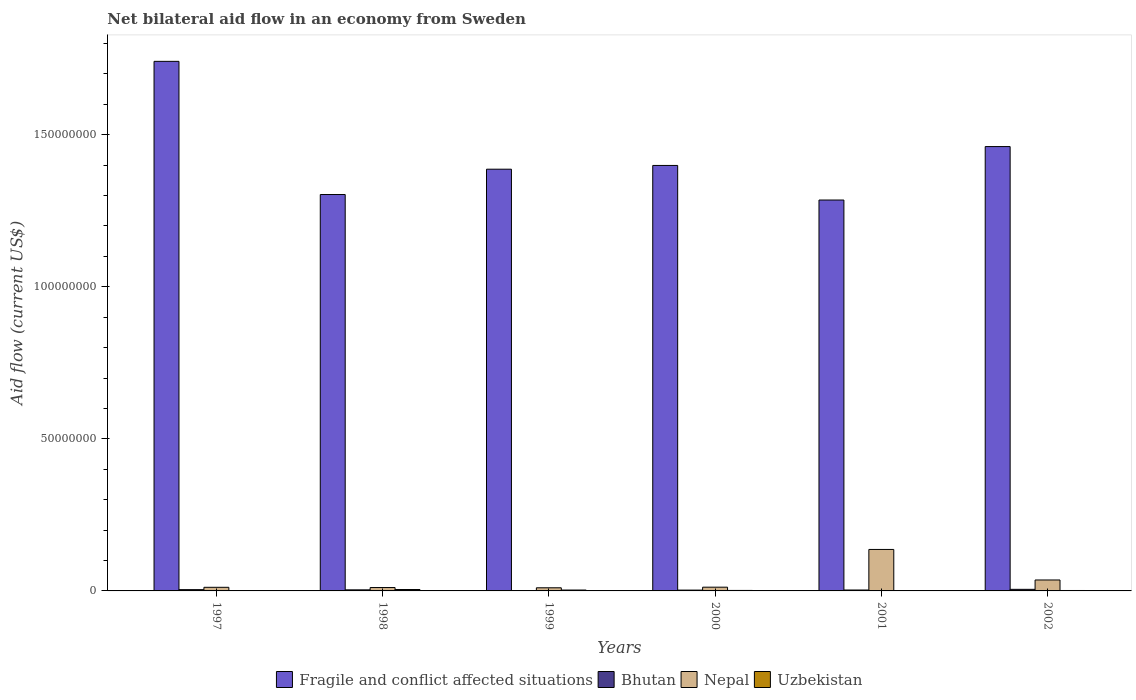How many different coloured bars are there?
Your answer should be compact. 4. Are the number of bars per tick equal to the number of legend labels?
Give a very brief answer. Yes. Are the number of bars on each tick of the X-axis equal?
Make the answer very short. Yes. How many bars are there on the 1st tick from the left?
Offer a terse response. 4. How many bars are there on the 6th tick from the right?
Give a very brief answer. 4. In how many cases, is the number of bars for a given year not equal to the number of legend labels?
Provide a short and direct response. 0. Across all years, what is the minimum net bilateral aid flow in Uzbekistan?
Provide a short and direct response. 4.00e+04. In which year was the net bilateral aid flow in Fragile and conflict affected situations maximum?
Provide a short and direct response. 1997. What is the total net bilateral aid flow in Nepal in the graph?
Your answer should be very brief. 2.18e+07. What is the difference between the net bilateral aid flow in Fragile and conflict affected situations in 1999 and that in 2001?
Ensure brevity in your answer.  1.01e+07. What is the difference between the net bilateral aid flow in Uzbekistan in 1997 and the net bilateral aid flow in Fragile and conflict affected situations in 1998?
Your answer should be very brief. -1.30e+08. What is the average net bilateral aid flow in Fragile and conflict affected situations per year?
Your answer should be very brief. 1.43e+08. In the year 2002, what is the difference between the net bilateral aid flow in Fragile and conflict affected situations and net bilateral aid flow in Nepal?
Provide a short and direct response. 1.43e+08. What is the ratio of the net bilateral aid flow in Fragile and conflict affected situations in 1997 to that in 1998?
Give a very brief answer. 1.34. Is the net bilateral aid flow in Uzbekistan in 1997 less than that in 2000?
Ensure brevity in your answer.  Yes. Is the difference between the net bilateral aid flow in Fragile and conflict affected situations in 1999 and 2000 greater than the difference between the net bilateral aid flow in Nepal in 1999 and 2000?
Offer a terse response. No. What is the difference between the highest and the second highest net bilateral aid flow in Fragile and conflict affected situations?
Your answer should be compact. 2.80e+07. What is the difference between the highest and the lowest net bilateral aid flow in Bhutan?
Provide a succinct answer. 4.50e+05. In how many years, is the net bilateral aid flow in Bhutan greater than the average net bilateral aid flow in Bhutan taken over all years?
Your response must be concise. 3. Is the sum of the net bilateral aid flow in Nepal in 1998 and 2001 greater than the maximum net bilateral aid flow in Uzbekistan across all years?
Keep it short and to the point. Yes. What does the 1st bar from the left in 1997 represents?
Provide a short and direct response. Fragile and conflict affected situations. What does the 4th bar from the right in 1999 represents?
Make the answer very short. Fragile and conflict affected situations. Is it the case that in every year, the sum of the net bilateral aid flow in Nepal and net bilateral aid flow in Bhutan is greater than the net bilateral aid flow in Fragile and conflict affected situations?
Ensure brevity in your answer.  No. How many years are there in the graph?
Make the answer very short. 6. Does the graph contain any zero values?
Ensure brevity in your answer.  No. What is the title of the graph?
Offer a very short reply. Net bilateral aid flow in an economy from Sweden. Does "Poland" appear as one of the legend labels in the graph?
Your answer should be very brief. No. What is the label or title of the X-axis?
Your answer should be compact. Years. What is the Aid flow (current US$) in Fragile and conflict affected situations in 1997?
Give a very brief answer. 1.74e+08. What is the Aid flow (current US$) in Nepal in 1997?
Give a very brief answer. 1.19e+06. What is the Aid flow (current US$) of Fragile and conflict affected situations in 1998?
Make the answer very short. 1.30e+08. What is the Aid flow (current US$) of Bhutan in 1998?
Ensure brevity in your answer.  3.50e+05. What is the Aid flow (current US$) of Nepal in 1998?
Your response must be concise. 1.11e+06. What is the Aid flow (current US$) of Uzbekistan in 1998?
Your response must be concise. 4.60e+05. What is the Aid flow (current US$) of Fragile and conflict affected situations in 1999?
Provide a short and direct response. 1.39e+08. What is the Aid flow (current US$) in Nepal in 1999?
Make the answer very short. 1.03e+06. What is the Aid flow (current US$) of Fragile and conflict affected situations in 2000?
Your answer should be very brief. 1.40e+08. What is the Aid flow (current US$) in Bhutan in 2000?
Your answer should be compact. 2.70e+05. What is the Aid flow (current US$) of Nepal in 2000?
Ensure brevity in your answer.  1.23e+06. What is the Aid flow (current US$) of Fragile and conflict affected situations in 2001?
Offer a terse response. 1.29e+08. What is the Aid flow (current US$) in Nepal in 2001?
Make the answer very short. 1.36e+07. What is the Aid flow (current US$) of Uzbekistan in 2001?
Provide a succinct answer. 4.00e+04. What is the Aid flow (current US$) of Fragile and conflict affected situations in 2002?
Offer a very short reply. 1.46e+08. What is the Aid flow (current US$) of Bhutan in 2002?
Keep it short and to the point. 5.20e+05. What is the Aid flow (current US$) in Nepal in 2002?
Provide a short and direct response. 3.60e+06. What is the Aid flow (current US$) of Uzbekistan in 2002?
Your answer should be compact. 1.40e+05. Across all years, what is the maximum Aid flow (current US$) of Fragile and conflict affected situations?
Provide a succinct answer. 1.74e+08. Across all years, what is the maximum Aid flow (current US$) of Bhutan?
Offer a very short reply. 5.20e+05. Across all years, what is the maximum Aid flow (current US$) of Nepal?
Your answer should be compact. 1.36e+07. Across all years, what is the maximum Aid flow (current US$) of Uzbekistan?
Offer a very short reply. 4.60e+05. Across all years, what is the minimum Aid flow (current US$) in Fragile and conflict affected situations?
Offer a terse response. 1.29e+08. Across all years, what is the minimum Aid flow (current US$) in Bhutan?
Your answer should be very brief. 7.00e+04. Across all years, what is the minimum Aid flow (current US$) of Nepal?
Ensure brevity in your answer.  1.03e+06. Across all years, what is the minimum Aid flow (current US$) in Uzbekistan?
Give a very brief answer. 4.00e+04. What is the total Aid flow (current US$) in Fragile and conflict affected situations in the graph?
Give a very brief answer. 8.58e+08. What is the total Aid flow (current US$) of Bhutan in the graph?
Your answer should be very brief. 1.93e+06. What is the total Aid flow (current US$) of Nepal in the graph?
Offer a terse response. 2.18e+07. What is the total Aid flow (current US$) in Uzbekistan in the graph?
Ensure brevity in your answer.  1.22e+06. What is the difference between the Aid flow (current US$) of Fragile and conflict affected situations in 1997 and that in 1998?
Provide a short and direct response. 4.38e+07. What is the difference between the Aid flow (current US$) in Uzbekistan in 1997 and that in 1998?
Your answer should be very brief. -3.30e+05. What is the difference between the Aid flow (current US$) in Fragile and conflict affected situations in 1997 and that in 1999?
Offer a terse response. 3.55e+07. What is the difference between the Aid flow (current US$) in Nepal in 1997 and that in 1999?
Make the answer very short. 1.60e+05. What is the difference between the Aid flow (current US$) in Fragile and conflict affected situations in 1997 and that in 2000?
Your answer should be compact. 3.42e+07. What is the difference between the Aid flow (current US$) in Bhutan in 1997 and that in 2000?
Make the answer very short. 1.50e+05. What is the difference between the Aid flow (current US$) in Fragile and conflict affected situations in 1997 and that in 2001?
Keep it short and to the point. 4.56e+07. What is the difference between the Aid flow (current US$) of Nepal in 1997 and that in 2001?
Offer a terse response. -1.24e+07. What is the difference between the Aid flow (current US$) of Fragile and conflict affected situations in 1997 and that in 2002?
Make the answer very short. 2.80e+07. What is the difference between the Aid flow (current US$) in Nepal in 1997 and that in 2002?
Give a very brief answer. -2.41e+06. What is the difference between the Aid flow (current US$) of Uzbekistan in 1997 and that in 2002?
Provide a succinct answer. -10000. What is the difference between the Aid flow (current US$) of Fragile and conflict affected situations in 1998 and that in 1999?
Give a very brief answer. -8.33e+06. What is the difference between the Aid flow (current US$) in Nepal in 1998 and that in 1999?
Give a very brief answer. 8.00e+04. What is the difference between the Aid flow (current US$) of Fragile and conflict affected situations in 1998 and that in 2000?
Keep it short and to the point. -9.56e+06. What is the difference between the Aid flow (current US$) of Uzbekistan in 1998 and that in 2000?
Make the answer very short. 3.00e+05. What is the difference between the Aid flow (current US$) in Fragile and conflict affected situations in 1998 and that in 2001?
Keep it short and to the point. 1.81e+06. What is the difference between the Aid flow (current US$) of Nepal in 1998 and that in 2001?
Your answer should be compact. -1.25e+07. What is the difference between the Aid flow (current US$) in Fragile and conflict affected situations in 1998 and that in 2002?
Ensure brevity in your answer.  -1.58e+07. What is the difference between the Aid flow (current US$) of Bhutan in 1998 and that in 2002?
Ensure brevity in your answer.  -1.70e+05. What is the difference between the Aid flow (current US$) of Nepal in 1998 and that in 2002?
Your answer should be compact. -2.49e+06. What is the difference between the Aid flow (current US$) in Fragile and conflict affected situations in 1999 and that in 2000?
Your answer should be very brief. -1.23e+06. What is the difference between the Aid flow (current US$) of Nepal in 1999 and that in 2000?
Offer a very short reply. -2.00e+05. What is the difference between the Aid flow (current US$) in Fragile and conflict affected situations in 1999 and that in 2001?
Your answer should be compact. 1.01e+07. What is the difference between the Aid flow (current US$) of Bhutan in 1999 and that in 2001?
Give a very brief answer. -2.30e+05. What is the difference between the Aid flow (current US$) in Nepal in 1999 and that in 2001?
Provide a short and direct response. -1.26e+07. What is the difference between the Aid flow (current US$) in Uzbekistan in 1999 and that in 2001?
Offer a very short reply. 2.50e+05. What is the difference between the Aid flow (current US$) in Fragile and conflict affected situations in 1999 and that in 2002?
Give a very brief answer. -7.44e+06. What is the difference between the Aid flow (current US$) in Bhutan in 1999 and that in 2002?
Ensure brevity in your answer.  -4.50e+05. What is the difference between the Aid flow (current US$) of Nepal in 1999 and that in 2002?
Keep it short and to the point. -2.57e+06. What is the difference between the Aid flow (current US$) of Uzbekistan in 1999 and that in 2002?
Provide a short and direct response. 1.50e+05. What is the difference between the Aid flow (current US$) of Fragile and conflict affected situations in 2000 and that in 2001?
Your answer should be very brief. 1.14e+07. What is the difference between the Aid flow (current US$) of Bhutan in 2000 and that in 2001?
Provide a short and direct response. -3.00e+04. What is the difference between the Aid flow (current US$) in Nepal in 2000 and that in 2001?
Your response must be concise. -1.24e+07. What is the difference between the Aid flow (current US$) in Fragile and conflict affected situations in 2000 and that in 2002?
Offer a very short reply. -6.21e+06. What is the difference between the Aid flow (current US$) in Bhutan in 2000 and that in 2002?
Provide a succinct answer. -2.50e+05. What is the difference between the Aid flow (current US$) in Nepal in 2000 and that in 2002?
Provide a succinct answer. -2.37e+06. What is the difference between the Aid flow (current US$) of Fragile and conflict affected situations in 2001 and that in 2002?
Keep it short and to the point. -1.76e+07. What is the difference between the Aid flow (current US$) of Nepal in 2001 and that in 2002?
Make the answer very short. 1.00e+07. What is the difference between the Aid flow (current US$) of Uzbekistan in 2001 and that in 2002?
Ensure brevity in your answer.  -1.00e+05. What is the difference between the Aid flow (current US$) of Fragile and conflict affected situations in 1997 and the Aid flow (current US$) of Bhutan in 1998?
Give a very brief answer. 1.74e+08. What is the difference between the Aid flow (current US$) of Fragile and conflict affected situations in 1997 and the Aid flow (current US$) of Nepal in 1998?
Your answer should be very brief. 1.73e+08. What is the difference between the Aid flow (current US$) in Fragile and conflict affected situations in 1997 and the Aid flow (current US$) in Uzbekistan in 1998?
Ensure brevity in your answer.  1.74e+08. What is the difference between the Aid flow (current US$) of Bhutan in 1997 and the Aid flow (current US$) of Nepal in 1998?
Keep it short and to the point. -6.90e+05. What is the difference between the Aid flow (current US$) in Nepal in 1997 and the Aid flow (current US$) in Uzbekistan in 1998?
Offer a very short reply. 7.30e+05. What is the difference between the Aid flow (current US$) in Fragile and conflict affected situations in 1997 and the Aid flow (current US$) in Bhutan in 1999?
Your answer should be compact. 1.74e+08. What is the difference between the Aid flow (current US$) in Fragile and conflict affected situations in 1997 and the Aid flow (current US$) in Nepal in 1999?
Offer a terse response. 1.73e+08. What is the difference between the Aid flow (current US$) of Fragile and conflict affected situations in 1997 and the Aid flow (current US$) of Uzbekistan in 1999?
Your response must be concise. 1.74e+08. What is the difference between the Aid flow (current US$) of Bhutan in 1997 and the Aid flow (current US$) of Nepal in 1999?
Keep it short and to the point. -6.10e+05. What is the difference between the Aid flow (current US$) in Fragile and conflict affected situations in 1997 and the Aid flow (current US$) in Bhutan in 2000?
Keep it short and to the point. 1.74e+08. What is the difference between the Aid flow (current US$) in Fragile and conflict affected situations in 1997 and the Aid flow (current US$) in Nepal in 2000?
Your answer should be compact. 1.73e+08. What is the difference between the Aid flow (current US$) of Fragile and conflict affected situations in 1997 and the Aid flow (current US$) of Uzbekistan in 2000?
Make the answer very short. 1.74e+08. What is the difference between the Aid flow (current US$) of Bhutan in 1997 and the Aid flow (current US$) of Nepal in 2000?
Offer a very short reply. -8.10e+05. What is the difference between the Aid flow (current US$) of Nepal in 1997 and the Aid flow (current US$) of Uzbekistan in 2000?
Offer a very short reply. 1.03e+06. What is the difference between the Aid flow (current US$) of Fragile and conflict affected situations in 1997 and the Aid flow (current US$) of Bhutan in 2001?
Keep it short and to the point. 1.74e+08. What is the difference between the Aid flow (current US$) in Fragile and conflict affected situations in 1997 and the Aid flow (current US$) in Nepal in 2001?
Ensure brevity in your answer.  1.60e+08. What is the difference between the Aid flow (current US$) in Fragile and conflict affected situations in 1997 and the Aid flow (current US$) in Uzbekistan in 2001?
Your answer should be very brief. 1.74e+08. What is the difference between the Aid flow (current US$) of Bhutan in 1997 and the Aid flow (current US$) of Nepal in 2001?
Your answer should be very brief. -1.32e+07. What is the difference between the Aid flow (current US$) of Nepal in 1997 and the Aid flow (current US$) of Uzbekistan in 2001?
Your answer should be very brief. 1.15e+06. What is the difference between the Aid flow (current US$) of Fragile and conflict affected situations in 1997 and the Aid flow (current US$) of Bhutan in 2002?
Provide a short and direct response. 1.74e+08. What is the difference between the Aid flow (current US$) in Fragile and conflict affected situations in 1997 and the Aid flow (current US$) in Nepal in 2002?
Ensure brevity in your answer.  1.71e+08. What is the difference between the Aid flow (current US$) in Fragile and conflict affected situations in 1997 and the Aid flow (current US$) in Uzbekistan in 2002?
Make the answer very short. 1.74e+08. What is the difference between the Aid flow (current US$) of Bhutan in 1997 and the Aid flow (current US$) of Nepal in 2002?
Offer a very short reply. -3.18e+06. What is the difference between the Aid flow (current US$) in Nepal in 1997 and the Aid flow (current US$) in Uzbekistan in 2002?
Offer a very short reply. 1.05e+06. What is the difference between the Aid flow (current US$) in Fragile and conflict affected situations in 1998 and the Aid flow (current US$) in Bhutan in 1999?
Your answer should be very brief. 1.30e+08. What is the difference between the Aid flow (current US$) in Fragile and conflict affected situations in 1998 and the Aid flow (current US$) in Nepal in 1999?
Your answer should be very brief. 1.29e+08. What is the difference between the Aid flow (current US$) of Fragile and conflict affected situations in 1998 and the Aid flow (current US$) of Uzbekistan in 1999?
Your answer should be compact. 1.30e+08. What is the difference between the Aid flow (current US$) in Bhutan in 1998 and the Aid flow (current US$) in Nepal in 1999?
Keep it short and to the point. -6.80e+05. What is the difference between the Aid flow (current US$) in Bhutan in 1998 and the Aid flow (current US$) in Uzbekistan in 1999?
Give a very brief answer. 6.00e+04. What is the difference between the Aid flow (current US$) of Nepal in 1998 and the Aid flow (current US$) of Uzbekistan in 1999?
Your answer should be very brief. 8.20e+05. What is the difference between the Aid flow (current US$) in Fragile and conflict affected situations in 1998 and the Aid flow (current US$) in Bhutan in 2000?
Ensure brevity in your answer.  1.30e+08. What is the difference between the Aid flow (current US$) of Fragile and conflict affected situations in 1998 and the Aid flow (current US$) of Nepal in 2000?
Your answer should be very brief. 1.29e+08. What is the difference between the Aid flow (current US$) in Fragile and conflict affected situations in 1998 and the Aid flow (current US$) in Uzbekistan in 2000?
Your response must be concise. 1.30e+08. What is the difference between the Aid flow (current US$) in Bhutan in 1998 and the Aid flow (current US$) in Nepal in 2000?
Offer a terse response. -8.80e+05. What is the difference between the Aid flow (current US$) in Bhutan in 1998 and the Aid flow (current US$) in Uzbekistan in 2000?
Provide a succinct answer. 1.90e+05. What is the difference between the Aid flow (current US$) of Nepal in 1998 and the Aid flow (current US$) of Uzbekistan in 2000?
Your answer should be compact. 9.50e+05. What is the difference between the Aid flow (current US$) of Fragile and conflict affected situations in 1998 and the Aid flow (current US$) of Bhutan in 2001?
Your answer should be compact. 1.30e+08. What is the difference between the Aid flow (current US$) of Fragile and conflict affected situations in 1998 and the Aid flow (current US$) of Nepal in 2001?
Give a very brief answer. 1.17e+08. What is the difference between the Aid flow (current US$) in Fragile and conflict affected situations in 1998 and the Aid flow (current US$) in Uzbekistan in 2001?
Your response must be concise. 1.30e+08. What is the difference between the Aid flow (current US$) in Bhutan in 1998 and the Aid flow (current US$) in Nepal in 2001?
Make the answer very short. -1.33e+07. What is the difference between the Aid flow (current US$) in Bhutan in 1998 and the Aid flow (current US$) in Uzbekistan in 2001?
Offer a very short reply. 3.10e+05. What is the difference between the Aid flow (current US$) of Nepal in 1998 and the Aid flow (current US$) of Uzbekistan in 2001?
Provide a short and direct response. 1.07e+06. What is the difference between the Aid flow (current US$) in Fragile and conflict affected situations in 1998 and the Aid flow (current US$) in Bhutan in 2002?
Make the answer very short. 1.30e+08. What is the difference between the Aid flow (current US$) of Fragile and conflict affected situations in 1998 and the Aid flow (current US$) of Nepal in 2002?
Make the answer very short. 1.27e+08. What is the difference between the Aid flow (current US$) of Fragile and conflict affected situations in 1998 and the Aid flow (current US$) of Uzbekistan in 2002?
Ensure brevity in your answer.  1.30e+08. What is the difference between the Aid flow (current US$) in Bhutan in 1998 and the Aid flow (current US$) in Nepal in 2002?
Offer a terse response. -3.25e+06. What is the difference between the Aid flow (current US$) of Bhutan in 1998 and the Aid flow (current US$) of Uzbekistan in 2002?
Your answer should be compact. 2.10e+05. What is the difference between the Aid flow (current US$) in Nepal in 1998 and the Aid flow (current US$) in Uzbekistan in 2002?
Provide a short and direct response. 9.70e+05. What is the difference between the Aid flow (current US$) in Fragile and conflict affected situations in 1999 and the Aid flow (current US$) in Bhutan in 2000?
Offer a very short reply. 1.38e+08. What is the difference between the Aid flow (current US$) of Fragile and conflict affected situations in 1999 and the Aid flow (current US$) of Nepal in 2000?
Provide a short and direct response. 1.37e+08. What is the difference between the Aid flow (current US$) of Fragile and conflict affected situations in 1999 and the Aid flow (current US$) of Uzbekistan in 2000?
Provide a succinct answer. 1.39e+08. What is the difference between the Aid flow (current US$) of Bhutan in 1999 and the Aid flow (current US$) of Nepal in 2000?
Offer a terse response. -1.16e+06. What is the difference between the Aid flow (current US$) of Bhutan in 1999 and the Aid flow (current US$) of Uzbekistan in 2000?
Offer a very short reply. -9.00e+04. What is the difference between the Aid flow (current US$) of Nepal in 1999 and the Aid flow (current US$) of Uzbekistan in 2000?
Keep it short and to the point. 8.70e+05. What is the difference between the Aid flow (current US$) of Fragile and conflict affected situations in 1999 and the Aid flow (current US$) of Bhutan in 2001?
Offer a very short reply. 1.38e+08. What is the difference between the Aid flow (current US$) in Fragile and conflict affected situations in 1999 and the Aid flow (current US$) in Nepal in 2001?
Ensure brevity in your answer.  1.25e+08. What is the difference between the Aid flow (current US$) in Fragile and conflict affected situations in 1999 and the Aid flow (current US$) in Uzbekistan in 2001?
Keep it short and to the point. 1.39e+08. What is the difference between the Aid flow (current US$) in Bhutan in 1999 and the Aid flow (current US$) in Nepal in 2001?
Keep it short and to the point. -1.36e+07. What is the difference between the Aid flow (current US$) in Bhutan in 1999 and the Aid flow (current US$) in Uzbekistan in 2001?
Offer a terse response. 3.00e+04. What is the difference between the Aid flow (current US$) of Nepal in 1999 and the Aid flow (current US$) of Uzbekistan in 2001?
Make the answer very short. 9.90e+05. What is the difference between the Aid flow (current US$) of Fragile and conflict affected situations in 1999 and the Aid flow (current US$) of Bhutan in 2002?
Offer a terse response. 1.38e+08. What is the difference between the Aid flow (current US$) of Fragile and conflict affected situations in 1999 and the Aid flow (current US$) of Nepal in 2002?
Provide a succinct answer. 1.35e+08. What is the difference between the Aid flow (current US$) of Fragile and conflict affected situations in 1999 and the Aid flow (current US$) of Uzbekistan in 2002?
Your answer should be very brief. 1.39e+08. What is the difference between the Aid flow (current US$) in Bhutan in 1999 and the Aid flow (current US$) in Nepal in 2002?
Make the answer very short. -3.53e+06. What is the difference between the Aid flow (current US$) in Bhutan in 1999 and the Aid flow (current US$) in Uzbekistan in 2002?
Your response must be concise. -7.00e+04. What is the difference between the Aid flow (current US$) of Nepal in 1999 and the Aid flow (current US$) of Uzbekistan in 2002?
Your response must be concise. 8.90e+05. What is the difference between the Aid flow (current US$) of Fragile and conflict affected situations in 2000 and the Aid flow (current US$) of Bhutan in 2001?
Provide a short and direct response. 1.40e+08. What is the difference between the Aid flow (current US$) in Fragile and conflict affected situations in 2000 and the Aid flow (current US$) in Nepal in 2001?
Offer a terse response. 1.26e+08. What is the difference between the Aid flow (current US$) in Fragile and conflict affected situations in 2000 and the Aid flow (current US$) in Uzbekistan in 2001?
Provide a succinct answer. 1.40e+08. What is the difference between the Aid flow (current US$) in Bhutan in 2000 and the Aid flow (current US$) in Nepal in 2001?
Ensure brevity in your answer.  -1.34e+07. What is the difference between the Aid flow (current US$) of Bhutan in 2000 and the Aid flow (current US$) of Uzbekistan in 2001?
Your answer should be very brief. 2.30e+05. What is the difference between the Aid flow (current US$) in Nepal in 2000 and the Aid flow (current US$) in Uzbekistan in 2001?
Ensure brevity in your answer.  1.19e+06. What is the difference between the Aid flow (current US$) of Fragile and conflict affected situations in 2000 and the Aid flow (current US$) of Bhutan in 2002?
Make the answer very short. 1.39e+08. What is the difference between the Aid flow (current US$) in Fragile and conflict affected situations in 2000 and the Aid flow (current US$) in Nepal in 2002?
Give a very brief answer. 1.36e+08. What is the difference between the Aid flow (current US$) in Fragile and conflict affected situations in 2000 and the Aid flow (current US$) in Uzbekistan in 2002?
Your answer should be compact. 1.40e+08. What is the difference between the Aid flow (current US$) in Bhutan in 2000 and the Aid flow (current US$) in Nepal in 2002?
Ensure brevity in your answer.  -3.33e+06. What is the difference between the Aid flow (current US$) of Bhutan in 2000 and the Aid flow (current US$) of Uzbekistan in 2002?
Offer a terse response. 1.30e+05. What is the difference between the Aid flow (current US$) of Nepal in 2000 and the Aid flow (current US$) of Uzbekistan in 2002?
Make the answer very short. 1.09e+06. What is the difference between the Aid flow (current US$) of Fragile and conflict affected situations in 2001 and the Aid flow (current US$) of Bhutan in 2002?
Keep it short and to the point. 1.28e+08. What is the difference between the Aid flow (current US$) in Fragile and conflict affected situations in 2001 and the Aid flow (current US$) in Nepal in 2002?
Your answer should be compact. 1.25e+08. What is the difference between the Aid flow (current US$) of Fragile and conflict affected situations in 2001 and the Aid flow (current US$) of Uzbekistan in 2002?
Keep it short and to the point. 1.28e+08. What is the difference between the Aid flow (current US$) in Bhutan in 2001 and the Aid flow (current US$) in Nepal in 2002?
Provide a succinct answer. -3.30e+06. What is the difference between the Aid flow (current US$) of Bhutan in 2001 and the Aid flow (current US$) of Uzbekistan in 2002?
Your answer should be compact. 1.60e+05. What is the difference between the Aid flow (current US$) of Nepal in 2001 and the Aid flow (current US$) of Uzbekistan in 2002?
Give a very brief answer. 1.35e+07. What is the average Aid flow (current US$) of Fragile and conflict affected situations per year?
Provide a succinct answer. 1.43e+08. What is the average Aid flow (current US$) of Bhutan per year?
Offer a very short reply. 3.22e+05. What is the average Aid flow (current US$) of Nepal per year?
Give a very brief answer. 3.63e+06. What is the average Aid flow (current US$) of Uzbekistan per year?
Your answer should be very brief. 2.03e+05. In the year 1997, what is the difference between the Aid flow (current US$) of Fragile and conflict affected situations and Aid flow (current US$) of Bhutan?
Your answer should be very brief. 1.74e+08. In the year 1997, what is the difference between the Aid flow (current US$) in Fragile and conflict affected situations and Aid flow (current US$) in Nepal?
Offer a very short reply. 1.73e+08. In the year 1997, what is the difference between the Aid flow (current US$) in Fragile and conflict affected situations and Aid flow (current US$) in Uzbekistan?
Your response must be concise. 1.74e+08. In the year 1997, what is the difference between the Aid flow (current US$) of Bhutan and Aid flow (current US$) of Nepal?
Make the answer very short. -7.70e+05. In the year 1997, what is the difference between the Aid flow (current US$) of Bhutan and Aid flow (current US$) of Uzbekistan?
Your answer should be compact. 2.90e+05. In the year 1997, what is the difference between the Aid flow (current US$) in Nepal and Aid flow (current US$) in Uzbekistan?
Your answer should be very brief. 1.06e+06. In the year 1998, what is the difference between the Aid flow (current US$) of Fragile and conflict affected situations and Aid flow (current US$) of Bhutan?
Your response must be concise. 1.30e+08. In the year 1998, what is the difference between the Aid flow (current US$) of Fragile and conflict affected situations and Aid flow (current US$) of Nepal?
Provide a succinct answer. 1.29e+08. In the year 1998, what is the difference between the Aid flow (current US$) of Fragile and conflict affected situations and Aid flow (current US$) of Uzbekistan?
Offer a very short reply. 1.30e+08. In the year 1998, what is the difference between the Aid flow (current US$) in Bhutan and Aid flow (current US$) in Nepal?
Give a very brief answer. -7.60e+05. In the year 1998, what is the difference between the Aid flow (current US$) in Bhutan and Aid flow (current US$) in Uzbekistan?
Make the answer very short. -1.10e+05. In the year 1998, what is the difference between the Aid flow (current US$) in Nepal and Aid flow (current US$) in Uzbekistan?
Ensure brevity in your answer.  6.50e+05. In the year 1999, what is the difference between the Aid flow (current US$) in Fragile and conflict affected situations and Aid flow (current US$) in Bhutan?
Ensure brevity in your answer.  1.39e+08. In the year 1999, what is the difference between the Aid flow (current US$) in Fragile and conflict affected situations and Aid flow (current US$) in Nepal?
Ensure brevity in your answer.  1.38e+08. In the year 1999, what is the difference between the Aid flow (current US$) of Fragile and conflict affected situations and Aid flow (current US$) of Uzbekistan?
Your answer should be compact. 1.38e+08. In the year 1999, what is the difference between the Aid flow (current US$) of Bhutan and Aid flow (current US$) of Nepal?
Your answer should be compact. -9.60e+05. In the year 1999, what is the difference between the Aid flow (current US$) in Nepal and Aid flow (current US$) in Uzbekistan?
Make the answer very short. 7.40e+05. In the year 2000, what is the difference between the Aid flow (current US$) of Fragile and conflict affected situations and Aid flow (current US$) of Bhutan?
Provide a short and direct response. 1.40e+08. In the year 2000, what is the difference between the Aid flow (current US$) in Fragile and conflict affected situations and Aid flow (current US$) in Nepal?
Give a very brief answer. 1.39e+08. In the year 2000, what is the difference between the Aid flow (current US$) of Fragile and conflict affected situations and Aid flow (current US$) of Uzbekistan?
Keep it short and to the point. 1.40e+08. In the year 2000, what is the difference between the Aid flow (current US$) of Bhutan and Aid flow (current US$) of Nepal?
Provide a short and direct response. -9.60e+05. In the year 2000, what is the difference between the Aid flow (current US$) in Nepal and Aid flow (current US$) in Uzbekistan?
Offer a very short reply. 1.07e+06. In the year 2001, what is the difference between the Aid flow (current US$) of Fragile and conflict affected situations and Aid flow (current US$) of Bhutan?
Provide a succinct answer. 1.28e+08. In the year 2001, what is the difference between the Aid flow (current US$) of Fragile and conflict affected situations and Aid flow (current US$) of Nepal?
Provide a succinct answer. 1.15e+08. In the year 2001, what is the difference between the Aid flow (current US$) in Fragile and conflict affected situations and Aid flow (current US$) in Uzbekistan?
Provide a short and direct response. 1.28e+08. In the year 2001, what is the difference between the Aid flow (current US$) of Bhutan and Aid flow (current US$) of Nepal?
Ensure brevity in your answer.  -1.33e+07. In the year 2001, what is the difference between the Aid flow (current US$) of Nepal and Aid flow (current US$) of Uzbekistan?
Give a very brief answer. 1.36e+07. In the year 2002, what is the difference between the Aid flow (current US$) of Fragile and conflict affected situations and Aid flow (current US$) of Bhutan?
Make the answer very short. 1.46e+08. In the year 2002, what is the difference between the Aid flow (current US$) of Fragile and conflict affected situations and Aid flow (current US$) of Nepal?
Your response must be concise. 1.43e+08. In the year 2002, what is the difference between the Aid flow (current US$) of Fragile and conflict affected situations and Aid flow (current US$) of Uzbekistan?
Your answer should be very brief. 1.46e+08. In the year 2002, what is the difference between the Aid flow (current US$) of Bhutan and Aid flow (current US$) of Nepal?
Keep it short and to the point. -3.08e+06. In the year 2002, what is the difference between the Aid flow (current US$) of Nepal and Aid flow (current US$) of Uzbekistan?
Offer a very short reply. 3.46e+06. What is the ratio of the Aid flow (current US$) in Fragile and conflict affected situations in 1997 to that in 1998?
Your answer should be very brief. 1.34. What is the ratio of the Aid flow (current US$) of Bhutan in 1997 to that in 1998?
Ensure brevity in your answer.  1.2. What is the ratio of the Aid flow (current US$) in Nepal in 1997 to that in 1998?
Give a very brief answer. 1.07. What is the ratio of the Aid flow (current US$) in Uzbekistan in 1997 to that in 1998?
Give a very brief answer. 0.28. What is the ratio of the Aid flow (current US$) of Fragile and conflict affected situations in 1997 to that in 1999?
Give a very brief answer. 1.26. What is the ratio of the Aid flow (current US$) of Bhutan in 1997 to that in 1999?
Provide a short and direct response. 6. What is the ratio of the Aid flow (current US$) in Nepal in 1997 to that in 1999?
Make the answer very short. 1.16. What is the ratio of the Aid flow (current US$) in Uzbekistan in 1997 to that in 1999?
Your answer should be very brief. 0.45. What is the ratio of the Aid flow (current US$) in Fragile and conflict affected situations in 1997 to that in 2000?
Make the answer very short. 1.24. What is the ratio of the Aid flow (current US$) of Bhutan in 1997 to that in 2000?
Give a very brief answer. 1.56. What is the ratio of the Aid flow (current US$) of Nepal in 1997 to that in 2000?
Your answer should be compact. 0.97. What is the ratio of the Aid flow (current US$) of Uzbekistan in 1997 to that in 2000?
Your answer should be compact. 0.81. What is the ratio of the Aid flow (current US$) of Fragile and conflict affected situations in 1997 to that in 2001?
Offer a terse response. 1.35. What is the ratio of the Aid flow (current US$) of Bhutan in 1997 to that in 2001?
Keep it short and to the point. 1.4. What is the ratio of the Aid flow (current US$) in Nepal in 1997 to that in 2001?
Offer a very short reply. 0.09. What is the ratio of the Aid flow (current US$) in Uzbekistan in 1997 to that in 2001?
Offer a very short reply. 3.25. What is the ratio of the Aid flow (current US$) of Fragile and conflict affected situations in 1997 to that in 2002?
Offer a terse response. 1.19. What is the ratio of the Aid flow (current US$) in Bhutan in 1997 to that in 2002?
Offer a terse response. 0.81. What is the ratio of the Aid flow (current US$) in Nepal in 1997 to that in 2002?
Provide a succinct answer. 0.33. What is the ratio of the Aid flow (current US$) of Fragile and conflict affected situations in 1998 to that in 1999?
Offer a very short reply. 0.94. What is the ratio of the Aid flow (current US$) of Bhutan in 1998 to that in 1999?
Provide a succinct answer. 5. What is the ratio of the Aid flow (current US$) in Nepal in 1998 to that in 1999?
Your response must be concise. 1.08. What is the ratio of the Aid flow (current US$) of Uzbekistan in 1998 to that in 1999?
Offer a very short reply. 1.59. What is the ratio of the Aid flow (current US$) of Fragile and conflict affected situations in 1998 to that in 2000?
Offer a terse response. 0.93. What is the ratio of the Aid flow (current US$) in Bhutan in 1998 to that in 2000?
Your answer should be compact. 1.3. What is the ratio of the Aid flow (current US$) of Nepal in 1998 to that in 2000?
Your answer should be compact. 0.9. What is the ratio of the Aid flow (current US$) of Uzbekistan in 1998 to that in 2000?
Offer a terse response. 2.88. What is the ratio of the Aid flow (current US$) in Fragile and conflict affected situations in 1998 to that in 2001?
Provide a succinct answer. 1.01. What is the ratio of the Aid flow (current US$) of Bhutan in 1998 to that in 2001?
Offer a terse response. 1.17. What is the ratio of the Aid flow (current US$) of Nepal in 1998 to that in 2001?
Offer a very short reply. 0.08. What is the ratio of the Aid flow (current US$) of Uzbekistan in 1998 to that in 2001?
Make the answer very short. 11.5. What is the ratio of the Aid flow (current US$) of Fragile and conflict affected situations in 1998 to that in 2002?
Ensure brevity in your answer.  0.89. What is the ratio of the Aid flow (current US$) of Bhutan in 1998 to that in 2002?
Provide a short and direct response. 0.67. What is the ratio of the Aid flow (current US$) in Nepal in 1998 to that in 2002?
Keep it short and to the point. 0.31. What is the ratio of the Aid flow (current US$) of Uzbekistan in 1998 to that in 2002?
Keep it short and to the point. 3.29. What is the ratio of the Aid flow (current US$) of Fragile and conflict affected situations in 1999 to that in 2000?
Give a very brief answer. 0.99. What is the ratio of the Aid flow (current US$) of Bhutan in 1999 to that in 2000?
Provide a short and direct response. 0.26. What is the ratio of the Aid flow (current US$) in Nepal in 1999 to that in 2000?
Your answer should be compact. 0.84. What is the ratio of the Aid flow (current US$) in Uzbekistan in 1999 to that in 2000?
Your answer should be very brief. 1.81. What is the ratio of the Aid flow (current US$) of Fragile and conflict affected situations in 1999 to that in 2001?
Provide a short and direct response. 1.08. What is the ratio of the Aid flow (current US$) in Bhutan in 1999 to that in 2001?
Give a very brief answer. 0.23. What is the ratio of the Aid flow (current US$) of Nepal in 1999 to that in 2001?
Your answer should be very brief. 0.08. What is the ratio of the Aid flow (current US$) of Uzbekistan in 1999 to that in 2001?
Make the answer very short. 7.25. What is the ratio of the Aid flow (current US$) of Fragile and conflict affected situations in 1999 to that in 2002?
Offer a very short reply. 0.95. What is the ratio of the Aid flow (current US$) of Bhutan in 1999 to that in 2002?
Make the answer very short. 0.13. What is the ratio of the Aid flow (current US$) of Nepal in 1999 to that in 2002?
Your answer should be compact. 0.29. What is the ratio of the Aid flow (current US$) of Uzbekistan in 1999 to that in 2002?
Your answer should be very brief. 2.07. What is the ratio of the Aid flow (current US$) in Fragile and conflict affected situations in 2000 to that in 2001?
Your answer should be compact. 1.09. What is the ratio of the Aid flow (current US$) in Nepal in 2000 to that in 2001?
Your answer should be very brief. 0.09. What is the ratio of the Aid flow (current US$) of Uzbekistan in 2000 to that in 2001?
Your response must be concise. 4. What is the ratio of the Aid flow (current US$) of Fragile and conflict affected situations in 2000 to that in 2002?
Offer a very short reply. 0.96. What is the ratio of the Aid flow (current US$) of Bhutan in 2000 to that in 2002?
Provide a succinct answer. 0.52. What is the ratio of the Aid flow (current US$) in Nepal in 2000 to that in 2002?
Give a very brief answer. 0.34. What is the ratio of the Aid flow (current US$) of Fragile and conflict affected situations in 2001 to that in 2002?
Ensure brevity in your answer.  0.88. What is the ratio of the Aid flow (current US$) of Bhutan in 2001 to that in 2002?
Make the answer very short. 0.58. What is the ratio of the Aid flow (current US$) of Nepal in 2001 to that in 2002?
Provide a succinct answer. 3.79. What is the ratio of the Aid flow (current US$) of Uzbekistan in 2001 to that in 2002?
Keep it short and to the point. 0.29. What is the difference between the highest and the second highest Aid flow (current US$) in Fragile and conflict affected situations?
Provide a succinct answer. 2.80e+07. What is the difference between the highest and the second highest Aid flow (current US$) in Nepal?
Make the answer very short. 1.00e+07. What is the difference between the highest and the lowest Aid flow (current US$) in Fragile and conflict affected situations?
Provide a short and direct response. 4.56e+07. What is the difference between the highest and the lowest Aid flow (current US$) of Nepal?
Your response must be concise. 1.26e+07. What is the difference between the highest and the lowest Aid flow (current US$) in Uzbekistan?
Provide a short and direct response. 4.20e+05. 